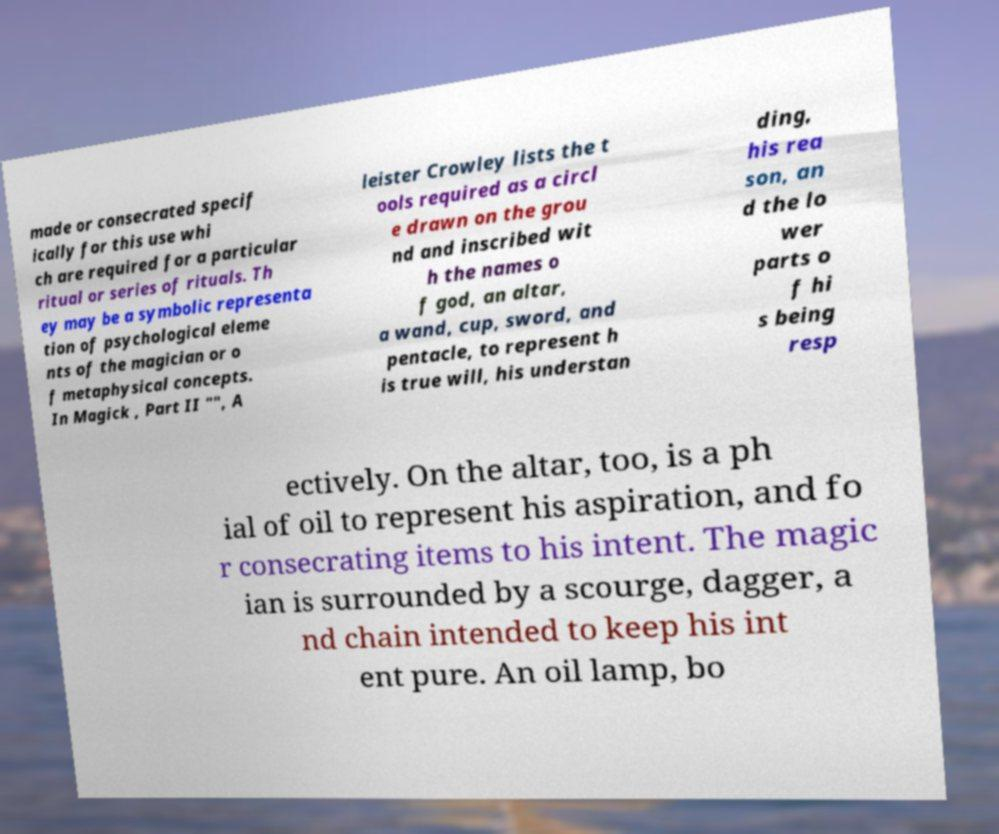Can you read and provide the text displayed in the image?This photo seems to have some interesting text. Can you extract and type it out for me? made or consecrated specif ically for this use whi ch are required for a particular ritual or series of rituals. Th ey may be a symbolic representa tion of psychological eleme nts of the magician or o f metaphysical concepts. In Magick , Part II "", A leister Crowley lists the t ools required as a circl e drawn on the grou nd and inscribed wit h the names o f god, an altar, a wand, cup, sword, and pentacle, to represent h is true will, his understan ding, his rea son, an d the lo wer parts o f hi s being resp ectively. On the altar, too, is a ph ial of oil to represent his aspiration, and fo r consecrating items to his intent. The magic ian is surrounded by a scourge, dagger, a nd chain intended to keep his int ent pure. An oil lamp, bo 